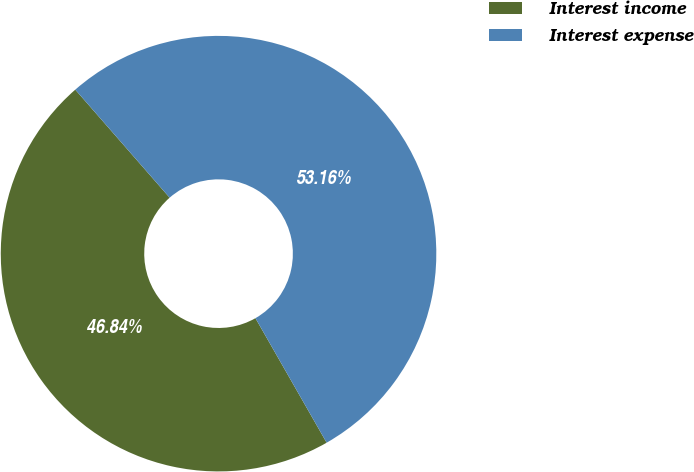<chart> <loc_0><loc_0><loc_500><loc_500><pie_chart><fcel>Interest income<fcel>Interest expense<nl><fcel>46.84%<fcel>53.16%<nl></chart> 